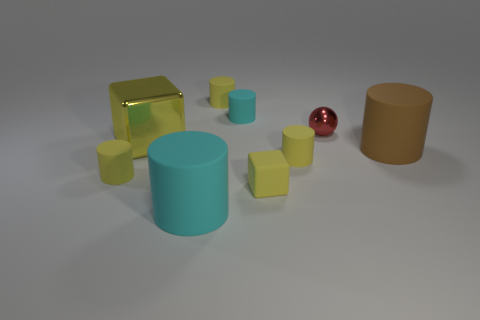Are there more rubber cylinders that are behind the large yellow metal block than cyan matte objects that are left of the red shiny sphere? After carefully examining the image, it appears that the number of rubber cylinders behind the large yellow metal block is equal to the number of cyan matte objects to the left of the red shiny sphere. Both groups contain two objects each. 